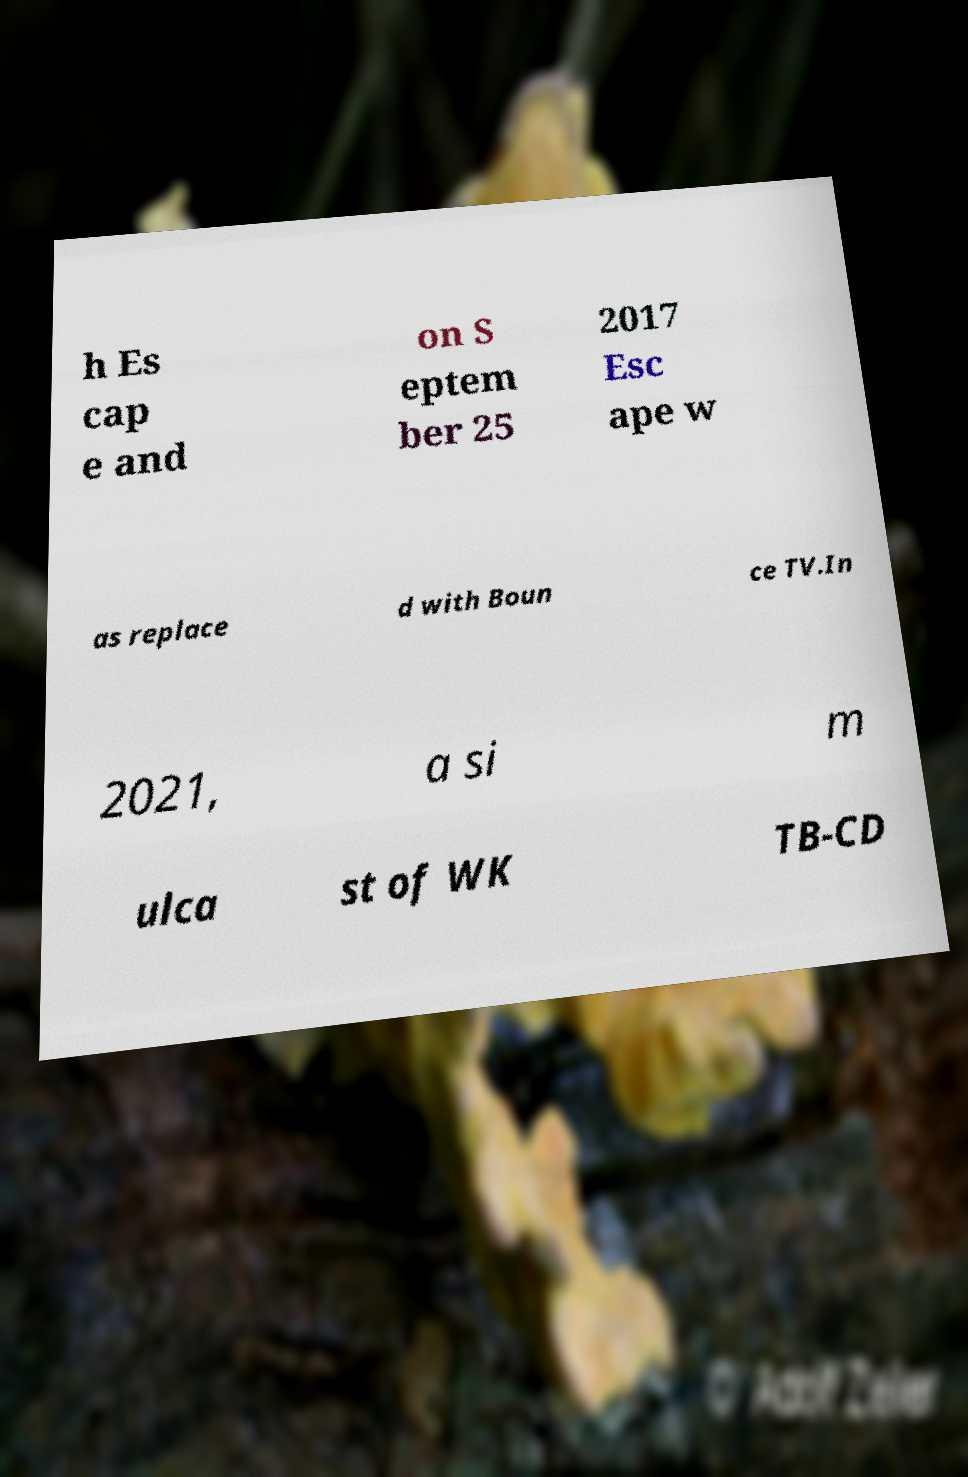Please identify and transcribe the text found in this image. h Es cap e and on S eptem ber 25 2017 Esc ape w as replace d with Boun ce TV.In 2021, a si m ulca st of WK TB-CD 